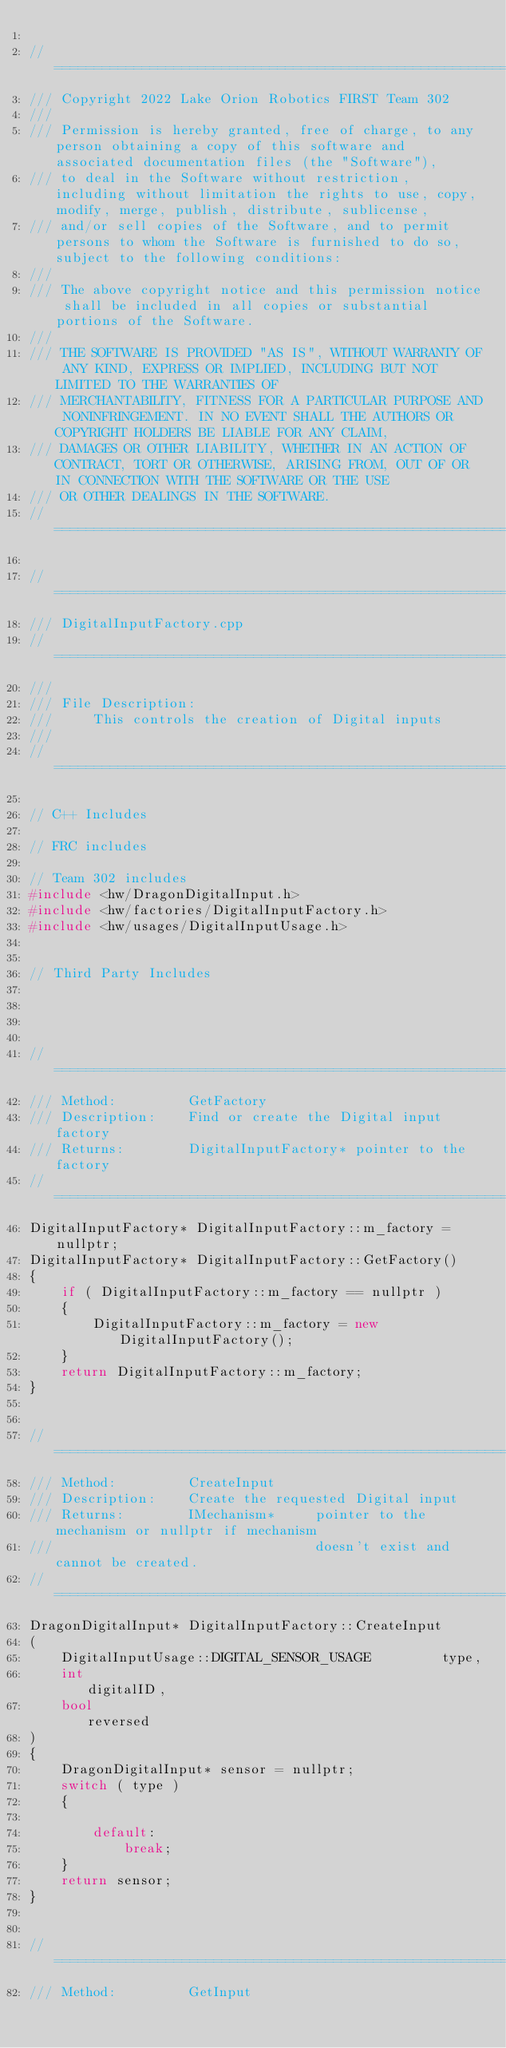<code> <loc_0><loc_0><loc_500><loc_500><_C++_>
//====================================================================================================================================================
/// Copyright 2022 Lake Orion Robotics FIRST Team 302
///
/// Permission is hereby granted, free of charge, to any person obtaining a copy of this software and associated documentation files (the "Software"),
/// to deal in the Software without restriction, including without limitation the rights to use, copy, modify, merge, publish, distribute, sublicense,
/// and/or sell copies of the Software, and to permit persons to whom the Software is furnished to do so, subject to the following conditions:
///
/// The above copyright notice and this permission notice shall be included in all copies or substantial portions of the Software.
///
/// THE SOFTWARE IS PROVIDED "AS IS", WITHOUT WARRANTY OF ANY KIND, EXPRESS OR IMPLIED, INCLUDING BUT NOT LIMITED TO THE WARRANTIES OF
/// MERCHANTABILITY, FITNESS FOR A PARTICULAR PURPOSE AND NONINFRINGEMENT. IN NO EVENT SHALL THE AUTHORS OR COPYRIGHT HOLDERS BE LIABLE FOR ANY CLAIM,
/// DAMAGES OR OTHER LIABILITY, WHETHER IN AN ACTION OF CONTRACT, TORT OR OTHERWISE, ARISING FROM, OUT OF OR IN CONNECTION WITH THE SOFTWARE OR THE USE
/// OR OTHER DEALINGS IN THE SOFTWARE.
//====================================================================================================================================================

//========================================================================================================
/// DigitalInputFactory.cpp
//========================================================================================================
///
/// File Description:
///     This controls the creation of Digital inputs
///
//========================================================================================================

// C++ Includes

// FRC includes

// Team 302 includes
#include <hw/DragonDigitalInput.h>
#include <hw/factories/DigitalInputFactory.h>
#include <hw/usages/DigitalInputUsage.h>


// Third Party Includes




//=====================================================================================
/// Method:         GetFactory
/// Description:    Find or create the Digital input factory
/// Returns:        DigitalInputFactory* pointer to the factory
//=====================================================================================
DigitalInputFactory* DigitalInputFactory::m_factory = nullptr;
DigitalInputFactory* DigitalInputFactory::GetFactory()
{
	if ( DigitalInputFactory::m_factory == nullptr )
	{
		DigitalInputFactory::m_factory = new DigitalInputFactory();
	}
	return DigitalInputFactory::m_factory;
}


//=====================================================================================
/// Method:         CreateInput
/// Description:    Create the requested Digital input
/// Returns:        IMechanism*     pointer to the mechanism or nullptr if mechanism 
///                                 doesn't exist and cannot be created.
//=====================================================================================
DragonDigitalInput* DigitalInputFactory::CreateInput
(
    DigitalInputUsage::DIGITAL_SENSOR_USAGE			type,
    int 						                    digitalID,
    bool						                    reversed
)
{
    DragonDigitalInput* sensor = nullptr;
    switch ( type )
    {

        default:
            break;
    }
    return sensor;
}


//=====================================================================================
/// Method:         GetInput</code> 